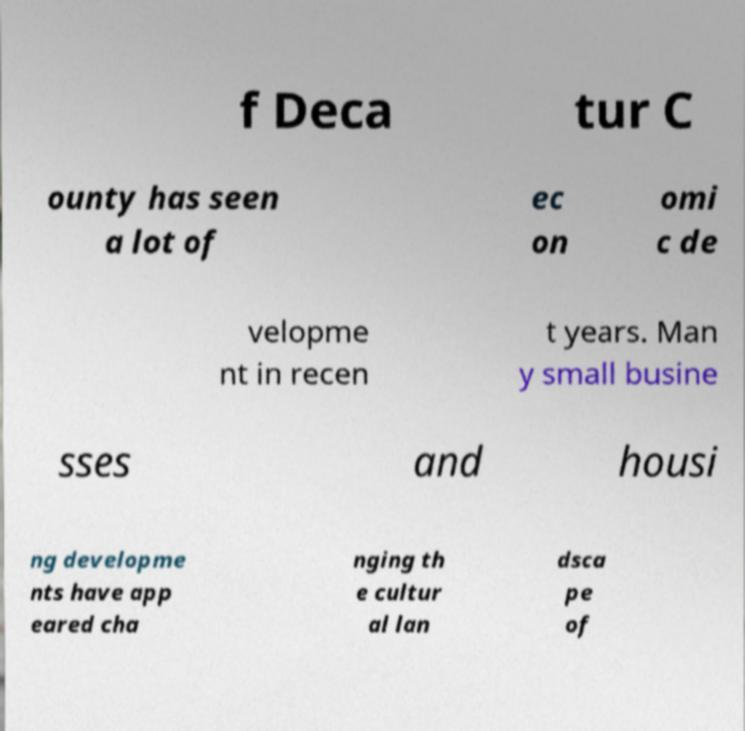Could you assist in decoding the text presented in this image and type it out clearly? f Deca tur C ounty has seen a lot of ec on omi c de velopme nt in recen t years. Man y small busine sses and housi ng developme nts have app eared cha nging th e cultur al lan dsca pe of 